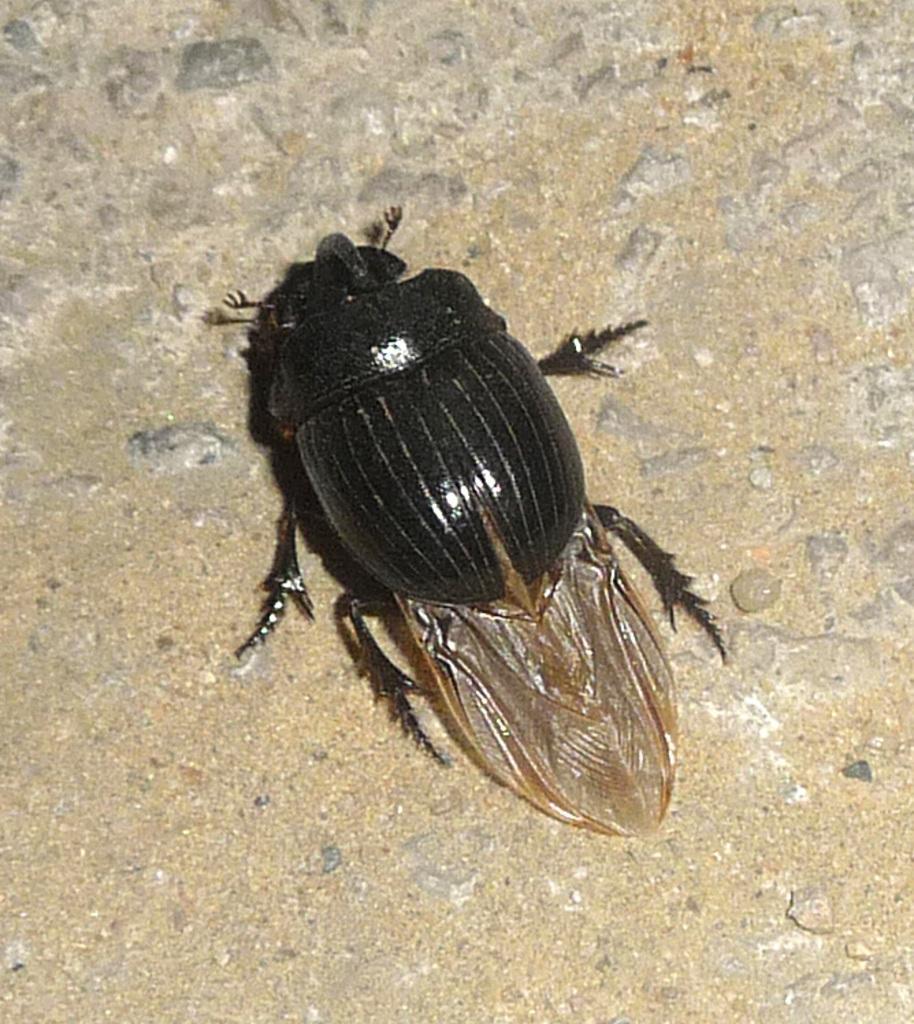How would you summarize this image in a sentence or two? In the image I can see a insect on the floor. 